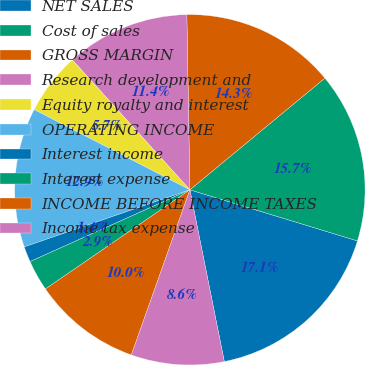Convert chart to OTSL. <chart><loc_0><loc_0><loc_500><loc_500><pie_chart><fcel>NET SALES<fcel>Cost of sales<fcel>GROSS MARGIN<fcel>Research development and<fcel>Equity royalty and interest<fcel>OPERATING INCOME<fcel>Interest income<fcel>Interest expense<fcel>INCOME BEFORE INCOME TAXES<fcel>Income tax expense<nl><fcel>17.14%<fcel>15.71%<fcel>14.28%<fcel>11.43%<fcel>5.72%<fcel>12.86%<fcel>1.43%<fcel>2.86%<fcel>10.0%<fcel>8.57%<nl></chart> 